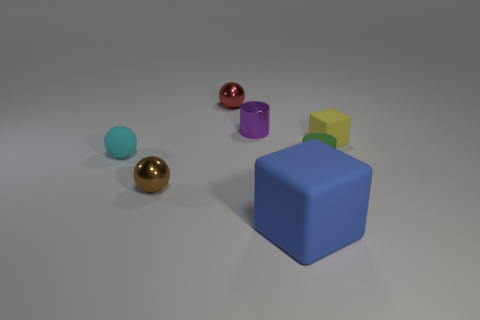Add 2 yellow cylinders. How many objects exist? 9 Subtract all cylinders. How many objects are left? 5 Subtract all small red things. Subtract all metal objects. How many objects are left? 3 Add 4 brown shiny things. How many brown shiny things are left? 5 Add 7 big brown rubber balls. How many big brown rubber balls exist? 7 Subtract 1 green cylinders. How many objects are left? 6 